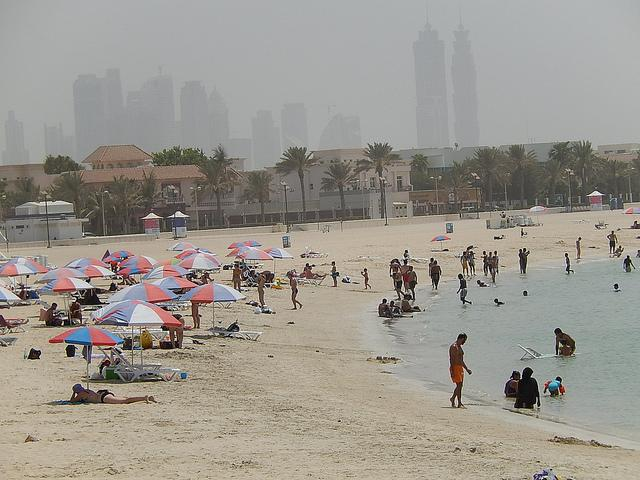Why are all the umbrellas there? Please explain your reasoning. sun protection. The umbrellas block sun. 